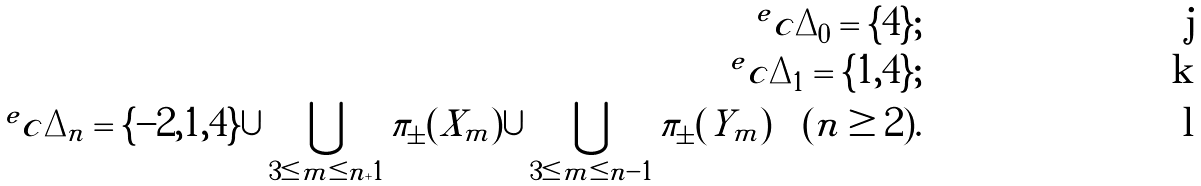<formula> <loc_0><loc_0><loc_500><loc_500>^ { e } c { \Delta _ { 0 } } = \{ 4 \} ; \\ ^ { e } c { \Delta _ { 1 } } = \{ 1 , 4 \} ; \\ ^ { e } c { \Delta _ { n } } = \{ - 2 , 1 , 4 \} \cup \bigcup _ { 3 \leq m \leq n + 1 } \pi _ { \pm } ( X _ { m } ) \cup \bigcup _ { 3 \leq m \leq n - 1 } \pi _ { \pm } ( Y _ { m } ) \quad ( n \geq 2 ) .</formula> 